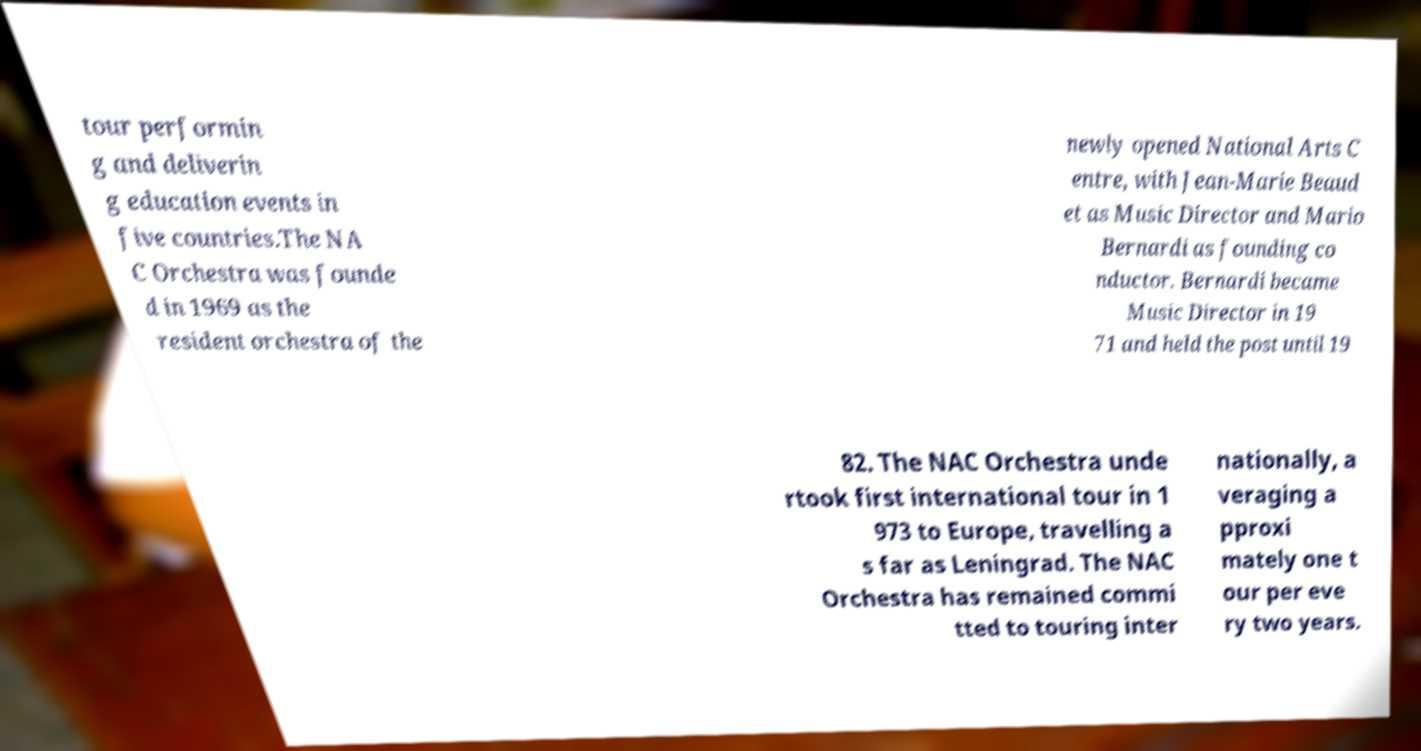For documentation purposes, I need the text within this image transcribed. Could you provide that? tour performin g and deliverin g education events in five countries.The NA C Orchestra was founde d in 1969 as the resident orchestra of the newly opened National Arts C entre, with Jean-Marie Beaud et as Music Director and Mario Bernardi as founding co nductor. Bernardi became Music Director in 19 71 and held the post until 19 82. The NAC Orchestra unde rtook first international tour in 1 973 to Europe, travelling a s far as Leningrad. The NAC Orchestra has remained commi tted to touring inter nationally, a veraging a pproxi mately one t our per eve ry two years. 